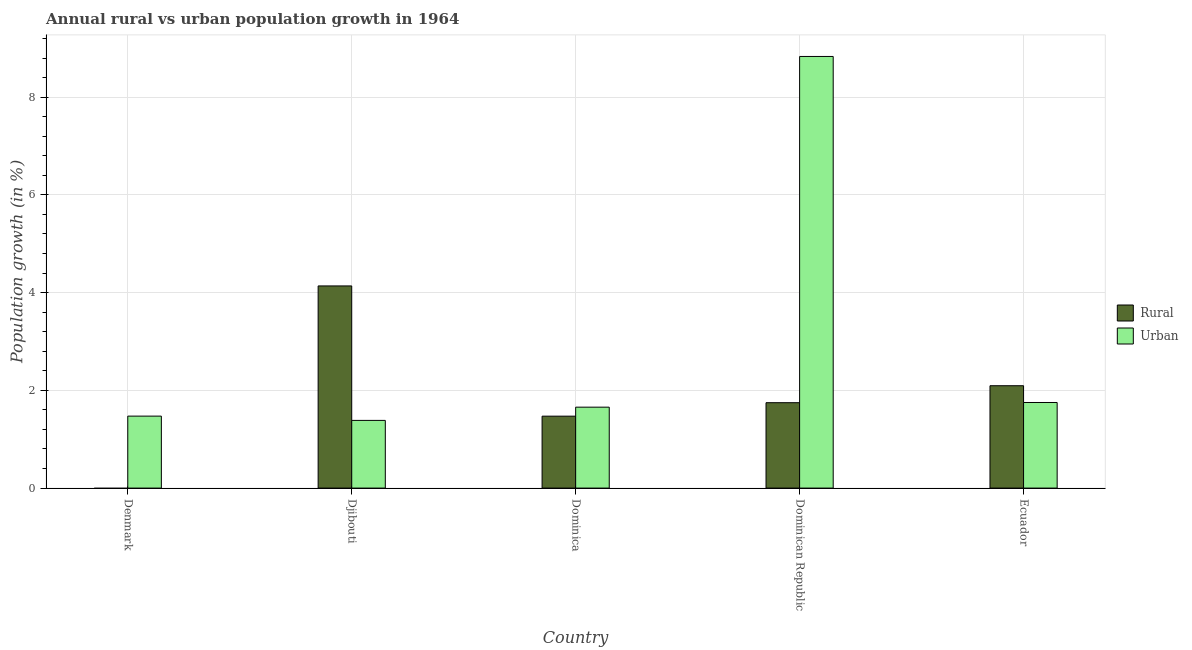How many different coloured bars are there?
Offer a terse response. 2. Are the number of bars on each tick of the X-axis equal?
Provide a short and direct response. No. How many bars are there on the 5th tick from the left?
Provide a succinct answer. 2. In how many cases, is the number of bars for a given country not equal to the number of legend labels?
Your response must be concise. 1. What is the urban population growth in Djibouti?
Provide a short and direct response. 1.39. Across all countries, what is the maximum urban population growth?
Offer a terse response. 8.83. Across all countries, what is the minimum urban population growth?
Keep it short and to the point. 1.39. In which country was the rural population growth maximum?
Your answer should be very brief. Djibouti. What is the total urban population growth in the graph?
Offer a very short reply. 15.1. What is the difference between the rural population growth in Dominica and that in Ecuador?
Your answer should be very brief. -0.62. What is the difference between the urban population growth in Djibouti and the rural population growth in Dominica?
Your answer should be compact. -0.09. What is the average rural population growth per country?
Keep it short and to the point. 1.89. What is the difference between the rural population growth and urban population growth in Djibouti?
Make the answer very short. 2.75. In how many countries, is the rural population growth greater than 1.6 %?
Your answer should be very brief. 3. What is the ratio of the rural population growth in Djibouti to that in Dominica?
Provide a short and direct response. 2.81. Is the difference between the urban population growth in Dominican Republic and Ecuador greater than the difference between the rural population growth in Dominican Republic and Ecuador?
Provide a succinct answer. Yes. What is the difference between the highest and the second highest rural population growth?
Provide a short and direct response. 2.04. What is the difference between the highest and the lowest rural population growth?
Make the answer very short. 4.14. Are all the bars in the graph horizontal?
Provide a succinct answer. No. How many countries are there in the graph?
Ensure brevity in your answer.  5. What is the difference between two consecutive major ticks on the Y-axis?
Your response must be concise. 2. Does the graph contain any zero values?
Your answer should be compact. Yes. How many legend labels are there?
Provide a short and direct response. 2. What is the title of the graph?
Provide a succinct answer. Annual rural vs urban population growth in 1964. What is the label or title of the Y-axis?
Provide a short and direct response. Population growth (in %). What is the Population growth (in %) in Rural in Denmark?
Your answer should be compact. 0. What is the Population growth (in %) in Urban  in Denmark?
Your answer should be very brief. 1.47. What is the Population growth (in %) in Rural in Djibouti?
Give a very brief answer. 4.14. What is the Population growth (in %) of Urban  in Djibouti?
Your answer should be very brief. 1.39. What is the Population growth (in %) of Rural in Dominica?
Give a very brief answer. 1.47. What is the Population growth (in %) of Urban  in Dominica?
Make the answer very short. 1.66. What is the Population growth (in %) in Rural in Dominican Republic?
Your answer should be very brief. 1.75. What is the Population growth (in %) of Urban  in Dominican Republic?
Offer a very short reply. 8.83. What is the Population growth (in %) of Rural in Ecuador?
Ensure brevity in your answer.  2.09. What is the Population growth (in %) in Urban  in Ecuador?
Make the answer very short. 1.75. Across all countries, what is the maximum Population growth (in %) of Rural?
Give a very brief answer. 4.14. Across all countries, what is the maximum Population growth (in %) in Urban ?
Ensure brevity in your answer.  8.83. Across all countries, what is the minimum Population growth (in %) of Urban ?
Make the answer very short. 1.39. What is the total Population growth (in %) of Rural in the graph?
Keep it short and to the point. 9.45. What is the total Population growth (in %) in Urban  in the graph?
Your answer should be very brief. 15.1. What is the difference between the Population growth (in %) in Urban  in Denmark and that in Djibouti?
Your answer should be compact. 0.09. What is the difference between the Population growth (in %) of Urban  in Denmark and that in Dominica?
Offer a terse response. -0.18. What is the difference between the Population growth (in %) in Urban  in Denmark and that in Dominican Republic?
Keep it short and to the point. -7.36. What is the difference between the Population growth (in %) of Urban  in Denmark and that in Ecuador?
Your response must be concise. -0.28. What is the difference between the Population growth (in %) of Rural in Djibouti and that in Dominica?
Provide a succinct answer. 2.67. What is the difference between the Population growth (in %) of Urban  in Djibouti and that in Dominica?
Give a very brief answer. -0.27. What is the difference between the Population growth (in %) of Rural in Djibouti and that in Dominican Republic?
Ensure brevity in your answer.  2.39. What is the difference between the Population growth (in %) of Urban  in Djibouti and that in Dominican Republic?
Make the answer very short. -7.45. What is the difference between the Population growth (in %) of Rural in Djibouti and that in Ecuador?
Provide a succinct answer. 2.04. What is the difference between the Population growth (in %) of Urban  in Djibouti and that in Ecuador?
Your answer should be very brief. -0.37. What is the difference between the Population growth (in %) in Rural in Dominica and that in Dominican Republic?
Provide a succinct answer. -0.28. What is the difference between the Population growth (in %) of Urban  in Dominica and that in Dominican Republic?
Your response must be concise. -7.18. What is the difference between the Population growth (in %) of Rural in Dominica and that in Ecuador?
Ensure brevity in your answer.  -0.62. What is the difference between the Population growth (in %) of Urban  in Dominica and that in Ecuador?
Give a very brief answer. -0.1. What is the difference between the Population growth (in %) of Rural in Dominican Republic and that in Ecuador?
Your answer should be very brief. -0.35. What is the difference between the Population growth (in %) in Urban  in Dominican Republic and that in Ecuador?
Your answer should be compact. 7.08. What is the difference between the Population growth (in %) of Rural in Djibouti and the Population growth (in %) of Urban  in Dominica?
Offer a very short reply. 2.48. What is the difference between the Population growth (in %) in Rural in Djibouti and the Population growth (in %) in Urban  in Dominican Republic?
Your response must be concise. -4.7. What is the difference between the Population growth (in %) of Rural in Djibouti and the Population growth (in %) of Urban  in Ecuador?
Provide a succinct answer. 2.39. What is the difference between the Population growth (in %) in Rural in Dominica and the Population growth (in %) in Urban  in Dominican Republic?
Offer a very short reply. -7.36. What is the difference between the Population growth (in %) in Rural in Dominica and the Population growth (in %) in Urban  in Ecuador?
Your response must be concise. -0.28. What is the difference between the Population growth (in %) in Rural in Dominican Republic and the Population growth (in %) in Urban  in Ecuador?
Provide a succinct answer. -0. What is the average Population growth (in %) in Rural per country?
Provide a succinct answer. 1.89. What is the average Population growth (in %) in Urban  per country?
Give a very brief answer. 3.02. What is the difference between the Population growth (in %) in Rural and Population growth (in %) in Urban  in Djibouti?
Your response must be concise. 2.75. What is the difference between the Population growth (in %) in Rural and Population growth (in %) in Urban  in Dominica?
Offer a very short reply. -0.18. What is the difference between the Population growth (in %) in Rural and Population growth (in %) in Urban  in Dominican Republic?
Provide a short and direct response. -7.09. What is the difference between the Population growth (in %) in Rural and Population growth (in %) in Urban  in Ecuador?
Offer a very short reply. 0.34. What is the ratio of the Population growth (in %) in Urban  in Denmark to that in Djibouti?
Offer a very short reply. 1.06. What is the ratio of the Population growth (in %) in Urban  in Denmark to that in Dominica?
Provide a succinct answer. 0.89. What is the ratio of the Population growth (in %) in Urban  in Denmark to that in Dominican Republic?
Ensure brevity in your answer.  0.17. What is the ratio of the Population growth (in %) of Urban  in Denmark to that in Ecuador?
Your answer should be very brief. 0.84. What is the ratio of the Population growth (in %) in Rural in Djibouti to that in Dominica?
Your answer should be compact. 2.81. What is the ratio of the Population growth (in %) in Urban  in Djibouti to that in Dominica?
Offer a terse response. 0.84. What is the ratio of the Population growth (in %) of Rural in Djibouti to that in Dominican Republic?
Provide a short and direct response. 2.37. What is the ratio of the Population growth (in %) in Urban  in Djibouti to that in Dominican Republic?
Provide a short and direct response. 0.16. What is the ratio of the Population growth (in %) of Rural in Djibouti to that in Ecuador?
Offer a terse response. 1.97. What is the ratio of the Population growth (in %) of Urban  in Djibouti to that in Ecuador?
Offer a terse response. 0.79. What is the ratio of the Population growth (in %) in Rural in Dominica to that in Dominican Republic?
Ensure brevity in your answer.  0.84. What is the ratio of the Population growth (in %) in Urban  in Dominica to that in Dominican Republic?
Give a very brief answer. 0.19. What is the ratio of the Population growth (in %) of Rural in Dominica to that in Ecuador?
Ensure brevity in your answer.  0.7. What is the ratio of the Population growth (in %) of Urban  in Dominica to that in Ecuador?
Offer a terse response. 0.95. What is the ratio of the Population growth (in %) in Rural in Dominican Republic to that in Ecuador?
Ensure brevity in your answer.  0.83. What is the ratio of the Population growth (in %) in Urban  in Dominican Republic to that in Ecuador?
Provide a short and direct response. 5.04. What is the difference between the highest and the second highest Population growth (in %) in Rural?
Provide a succinct answer. 2.04. What is the difference between the highest and the second highest Population growth (in %) in Urban ?
Your answer should be compact. 7.08. What is the difference between the highest and the lowest Population growth (in %) in Rural?
Give a very brief answer. 4.14. What is the difference between the highest and the lowest Population growth (in %) in Urban ?
Provide a succinct answer. 7.45. 